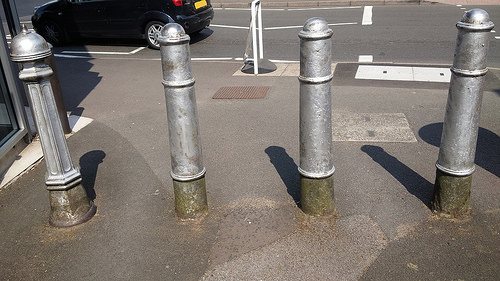<image>
Is there a pole to the right of the pole? No. The pole is not to the right of the pole. The horizontal positioning shows a different relationship. 